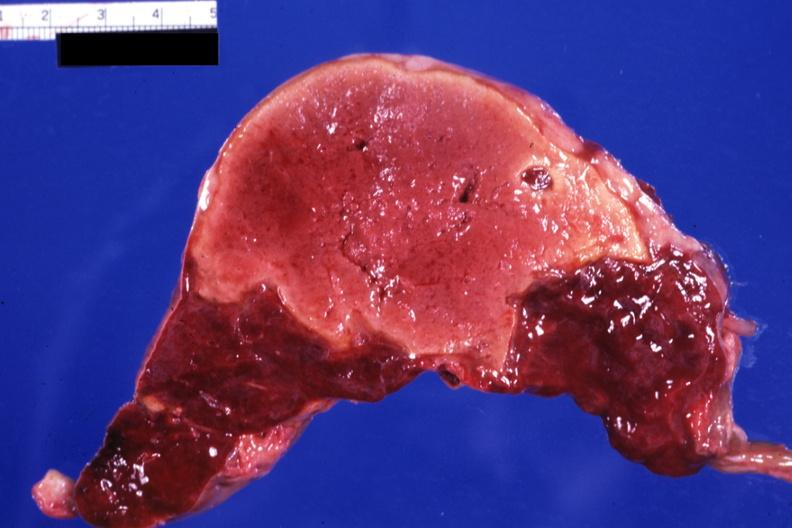s spleen present?
Answer the question using a single word or phrase. Yes 